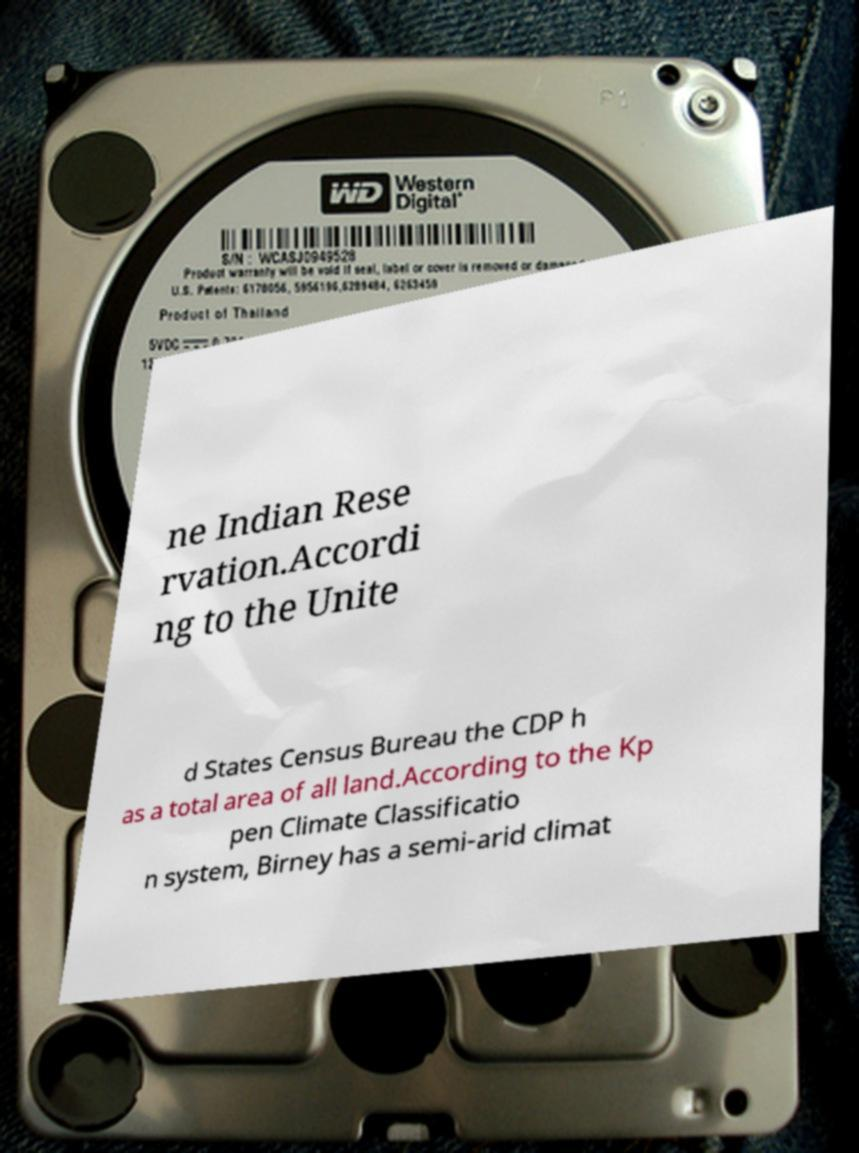Please read and relay the text visible in this image. What does it say? ne Indian Rese rvation.Accordi ng to the Unite d States Census Bureau the CDP h as a total area of all land.According to the Kp pen Climate Classificatio n system, Birney has a semi-arid climat 